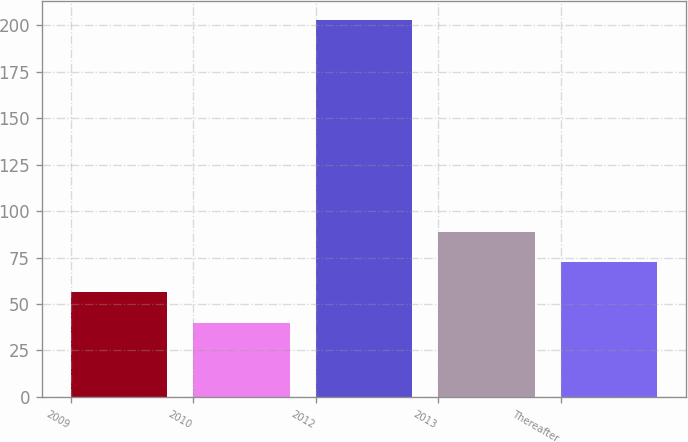Convert chart. <chart><loc_0><loc_0><loc_500><loc_500><bar_chart><fcel>2009<fcel>2010<fcel>2012<fcel>2013<fcel>Thereafter<nl><fcel>56.3<fcel>40<fcel>203<fcel>88.9<fcel>72.6<nl></chart> 